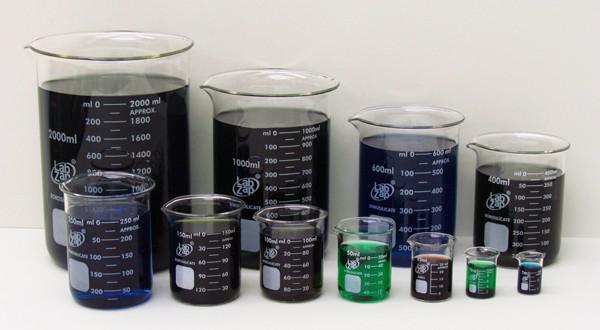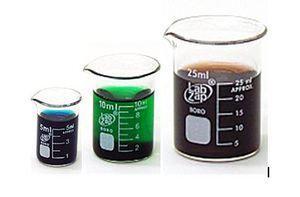The first image is the image on the left, the second image is the image on the right. Examine the images to the left and right. Is the description "There is no less than 14 filled beakers." accurate? Answer yes or no. Yes. The first image is the image on the left, the second image is the image on the right. For the images displayed, is the sentence "There is green liquid in both images." factually correct? Answer yes or no. Yes. 